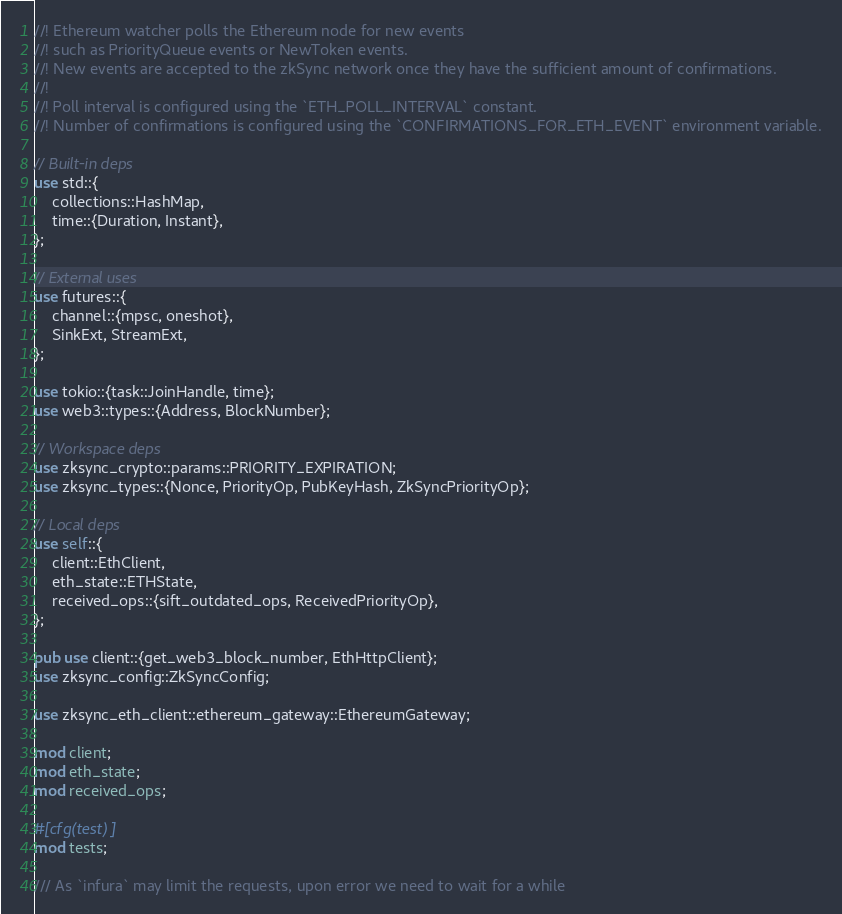Convert code to text. <code><loc_0><loc_0><loc_500><loc_500><_Rust_>//! Ethereum watcher polls the Ethereum node for new events
//! such as PriorityQueue events or NewToken events.
//! New events are accepted to the zkSync network once they have the sufficient amount of confirmations.
//!
//! Poll interval is configured using the `ETH_POLL_INTERVAL` constant.
//! Number of confirmations is configured using the `CONFIRMATIONS_FOR_ETH_EVENT` environment variable.

// Built-in deps
use std::{
    collections::HashMap,
    time::{Duration, Instant},
};

// External uses
use futures::{
    channel::{mpsc, oneshot},
    SinkExt, StreamExt,
};

use tokio::{task::JoinHandle, time};
use web3::types::{Address, BlockNumber};

// Workspace deps
use zksync_crypto::params::PRIORITY_EXPIRATION;
use zksync_types::{Nonce, PriorityOp, PubKeyHash, ZkSyncPriorityOp};

// Local deps
use self::{
    client::EthClient,
    eth_state::ETHState,
    received_ops::{sift_outdated_ops, ReceivedPriorityOp},
};

pub use client::{get_web3_block_number, EthHttpClient};
use zksync_config::ZkSyncConfig;

use zksync_eth_client::ethereum_gateway::EthereumGateway;

mod client;
mod eth_state;
mod received_ops;

#[cfg(test)]
mod tests;

/// As `infura` may limit the requests, upon error we need to wait for a while</code> 